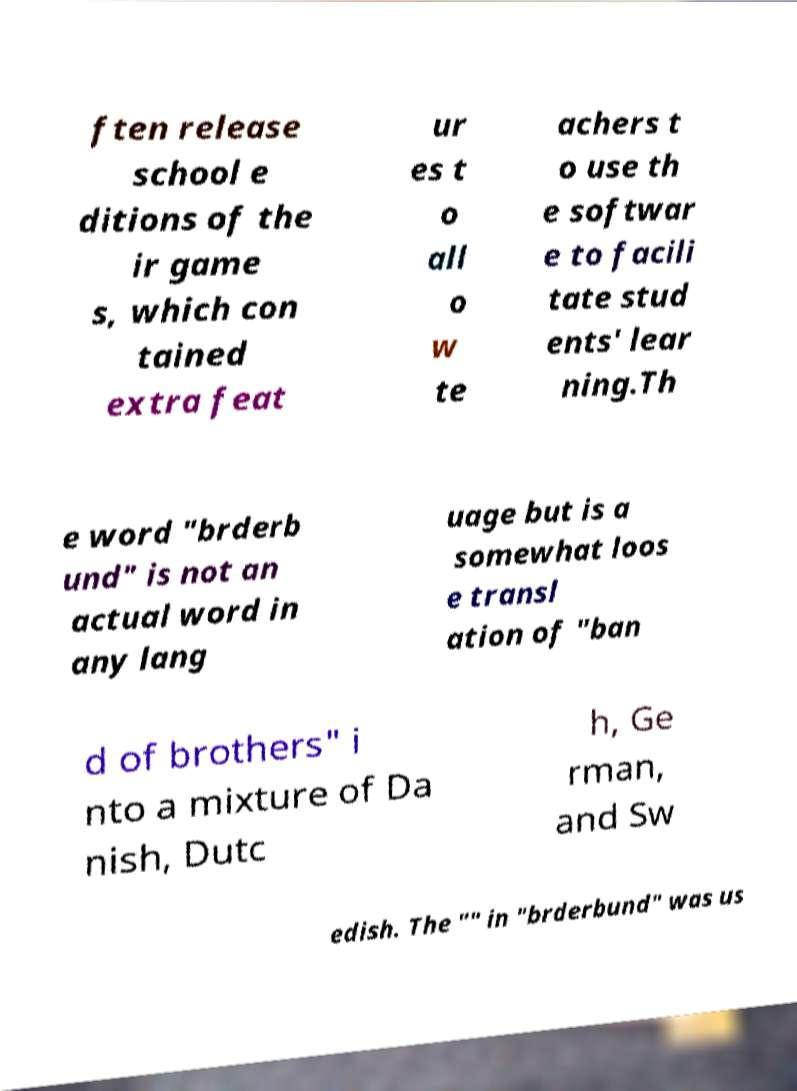Could you assist in decoding the text presented in this image and type it out clearly? ften release school e ditions of the ir game s, which con tained extra feat ur es t o all o w te achers t o use th e softwar e to facili tate stud ents' lear ning.Th e word "brderb und" is not an actual word in any lang uage but is a somewhat loos e transl ation of "ban d of brothers" i nto a mixture of Da nish, Dutc h, Ge rman, and Sw edish. The "" in "brderbund" was us 